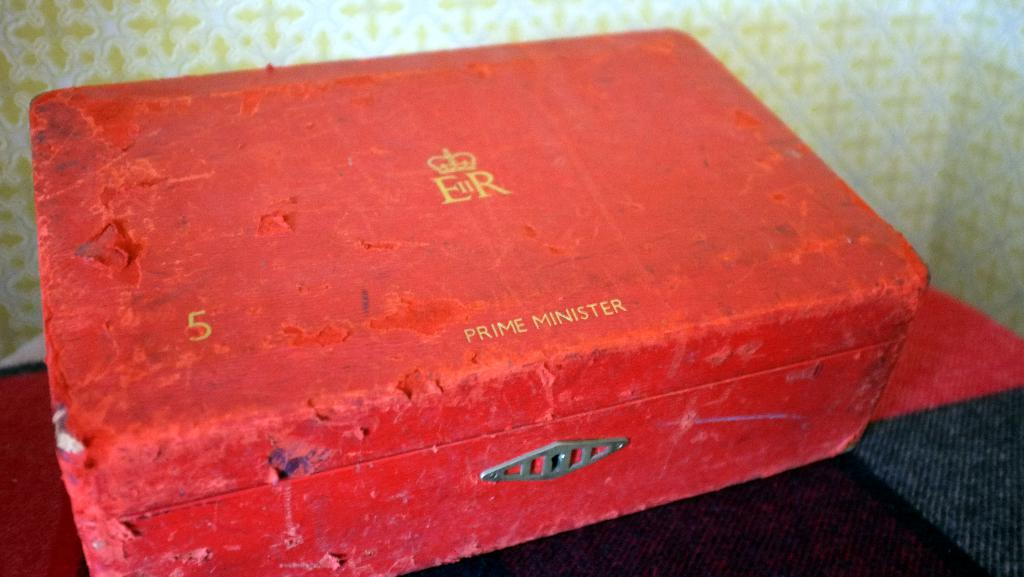<image>
Write a terse but informative summary of the picture. A old battered red suitcase with Prime Minister written on it. 